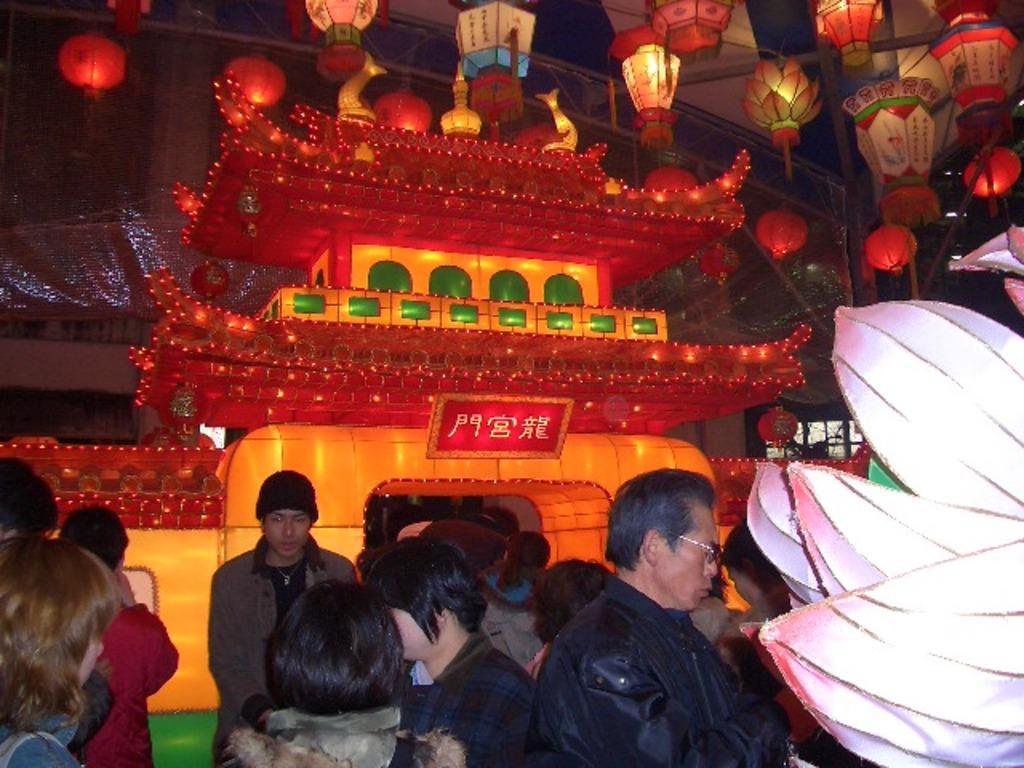Can you describe this image briefly? In this image we can see many people. One person is wearing a cap. Another person is wearing specs. And there are decorative items. Also there are lights hanged. 